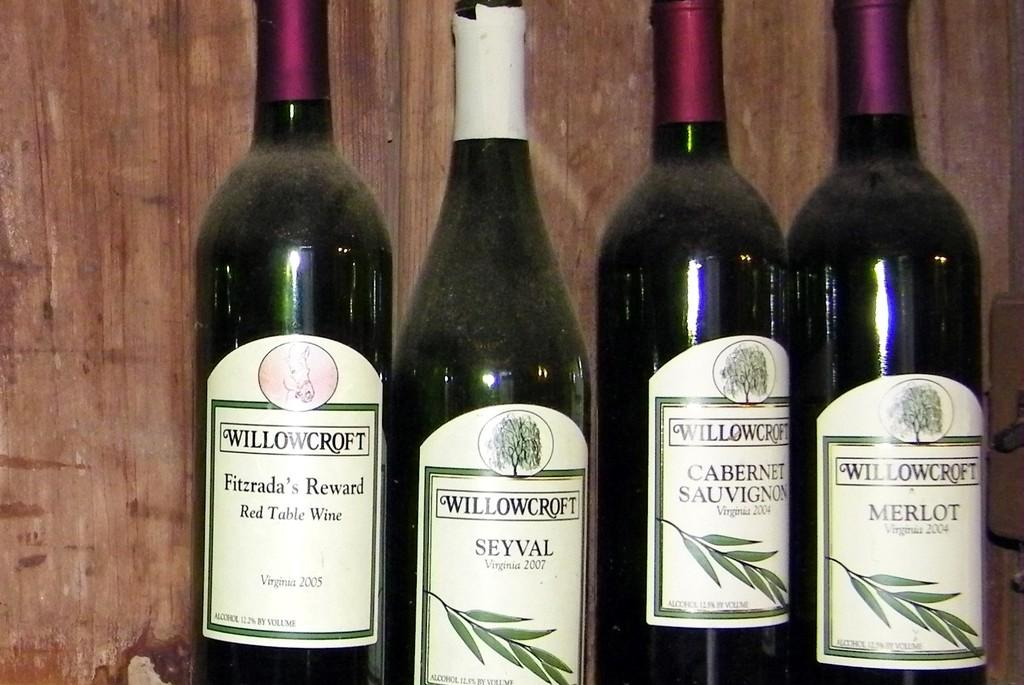Provide a one-sentence caption for the provided image. The four bottles of wine are from the company Willowcroft. 